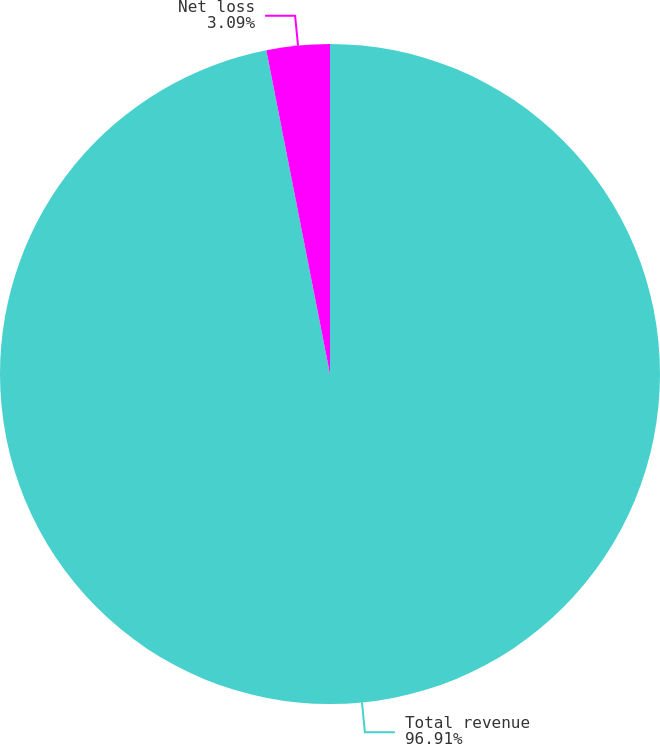Convert chart to OTSL. <chart><loc_0><loc_0><loc_500><loc_500><pie_chart><fcel>Total revenue<fcel>Net loss<nl><fcel>96.91%<fcel>3.09%<nl></chart> 